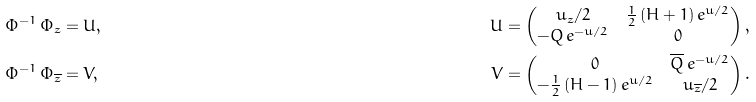Convert formula to latex. <formula><loc_0><loc_0><loc_500><loc_500>\Phi ^ { - 1 } \, \Phi _ { z } & = U , & \quad U & = \begin{pmatrix} u _ { z } / 2 & \frac { 1 } { 2 } \, ( H + 1 ) \, e ^ { u / 2 } \\ - Q \, e ^ { - u / 2 } & 0 \end{pmatrix} , \\ \Phi ^ { - 1 } \, \Phi _ { \overline { z } } & = V , & \quad V & = \begin{pmatrix} 0 & \overline { Q } \, e ^ { - u / 2 } \\ - \frac { 1 } { 2 } \, ( H - 1 ) \, e ^ { u / 2 } & u _ { \overline { z } } / 2 \end{pmatrix} .</formula> 